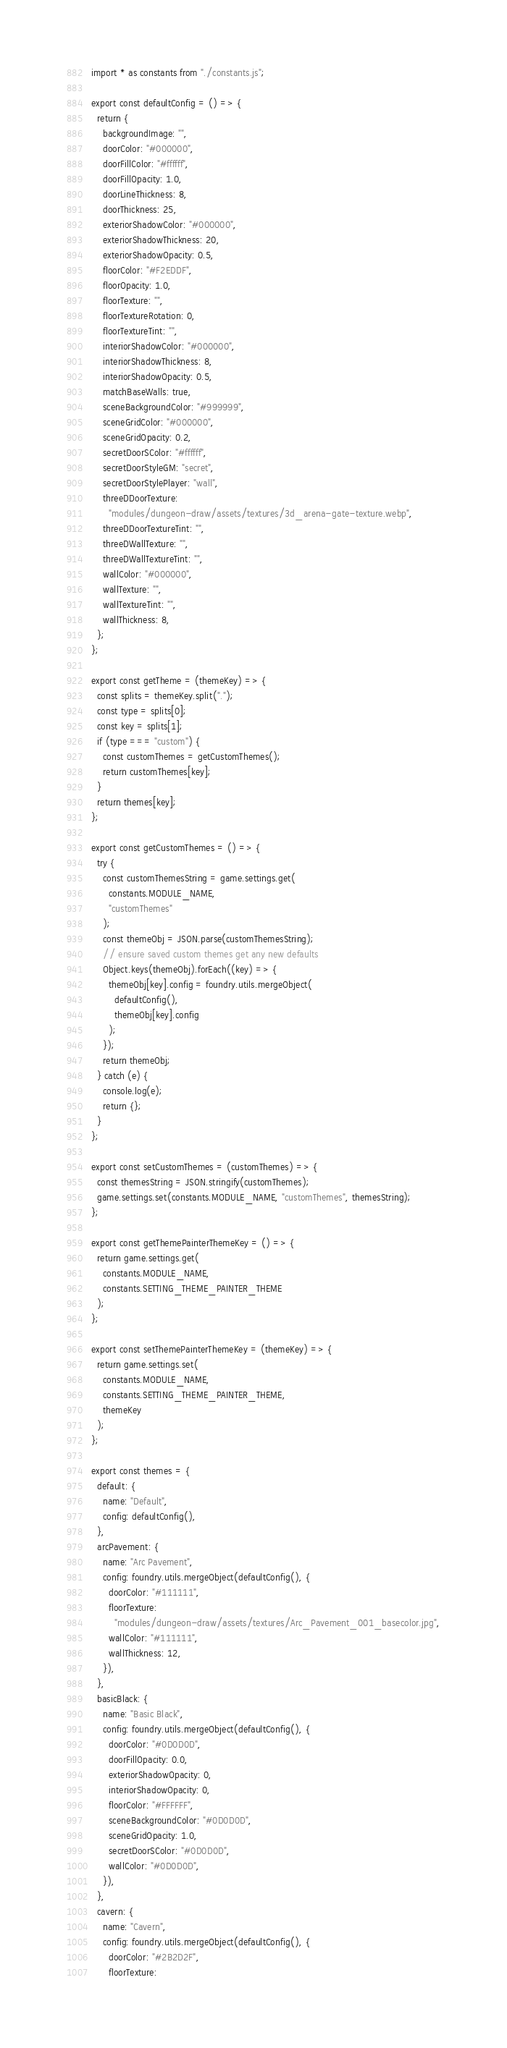<code> <loc_0><loc_0><loc_500><loc_500><_JavaScript_>import * as constants from "./constants.js";

export const defaultConfig = () => {
  return {
    backgroundImage: "",
    doorColor: "#000000",
    doorFillColor: "#ffffff",
    doorFillOpacity: 1.0,
    doorLineThickness: 8,
    doorThickness: 25,
    exteriorShadowColor: "#000000",
    exteriorShadowThickness: 20,
    exteriorShadowOpacity: 0.5,
    floorColor: "#F2EDDF",
    floorOpacity: 1.0,
    floorTexture: "",
    floorTextureRotation: 0,
    floorTextureTint: "",
    interiorShadowColor: "#000000",
    interiorShadowThickness: 8,
    interiorShadowOpacity: 0.5,
    matchBaseWalls: true,
    sceneBackgroundColor: "#999999",
    sceneGridColor: "#000000",
    sceneGridOpacity: 0.2,
    secretDoorSColor: "#ffffff",
    secretDoorStyleGM: "secret",
    secretDoorStylePlayer: "wall",
    threeDDoorTexture:
      "modules/dungeon-draw/assets/textures/3d_arena-gate-texture.webp",
    threeDDoorTextureTint: "",
    threeDWallTexture: "",
    threeDWallTextureTint: "",
    wallColor: "#000000",
    wallTexture: "",
    wallTextureTint: "",
    wallThickness: 8,
  };
};

export const getTheme = (themeKey) => {
  const splits = themeKey.split(".");
  const type = splits[0];
  const key = splits[1];
  if (type === "custom") {
    const customThemes = getCustomThemes();
    return customThemes[key];
  }
  return themes[key];
};

export const getCustomThemes = () => {
  try {
    const customThemesString = game.settings.get(
      constants.MODULE_NAME,
      "customThemes"
    );
    const themeObj = JSON.parse(customThemesString);
    // ensure saved custom themes get any new defaults
    Object.keys(themeObj).forEach((key) => {
      themeObj[key].config = foundry.utils.mergeObject(
        defaultConfig(),
        themeObj[key].config
      );
    });
    return themeObj;
  } catch (e) {
    console.log(e);
    return {};
  }
};

export const setCustomThemes = (customThemes) => {
  const themesString = JSON.stringify(customThemes);
  game.settings.set(constants.MODULE_NAME, "customThemes", themesString);
};

export const getThemePainterThemeKey = () => {
  return game.settings.get(
    constants.MODULE_NAME,
    constants.SETTING_THEME_PAINTER_THEME
  );
};

export const setThemePainterThemeKey = (themeKey) => {
  return game.settings.set(
    constants.MODULE_NAME,
    constants.SETTING_THEME_PAINTER_THEME,
    themeKey
  );
};

export const themes = {
  default: {
    name: "Default",
    config: defaultConfig(),
  },
  arcPavement: {
    name: "Arc Pavement",
    config: foundry.utils.mergeObject(defaultConfig(), {
      doorColor: "#111111",
      floorTexture:
        "modules/dungeon-draw/assets/textures/Arc_Pavement_001_basecolor.jpg",
      wallColor: "#111111",
      wallThickness: 12,
    }),
  },
  basicBlack: {
    name: "Basic Black",
    config: foundry.utils.mergeObject(defaultConfig(), {
      doorColor: "#0D0D0D",
      doorFillOpacity: 0.0,
      exteriorShadowOpacity: 0,
      interiorShadowOpacity: 0,
      floorColor: "#FFFFFF",
      sceneBackgroundColor: "#0D0D0D",
      sceneGridOpacity: 1.0,
      secretDoorSColor: "#0D0D0D",
      wallColor: "#0D0D0D",
    }),
  },
  cavern: {
    name: "Cavern",
    config: foundry.utils.mergeObject(defaultConfig(), {
      doorColor: "#2B2D2F",
      floorTexture:</code> 